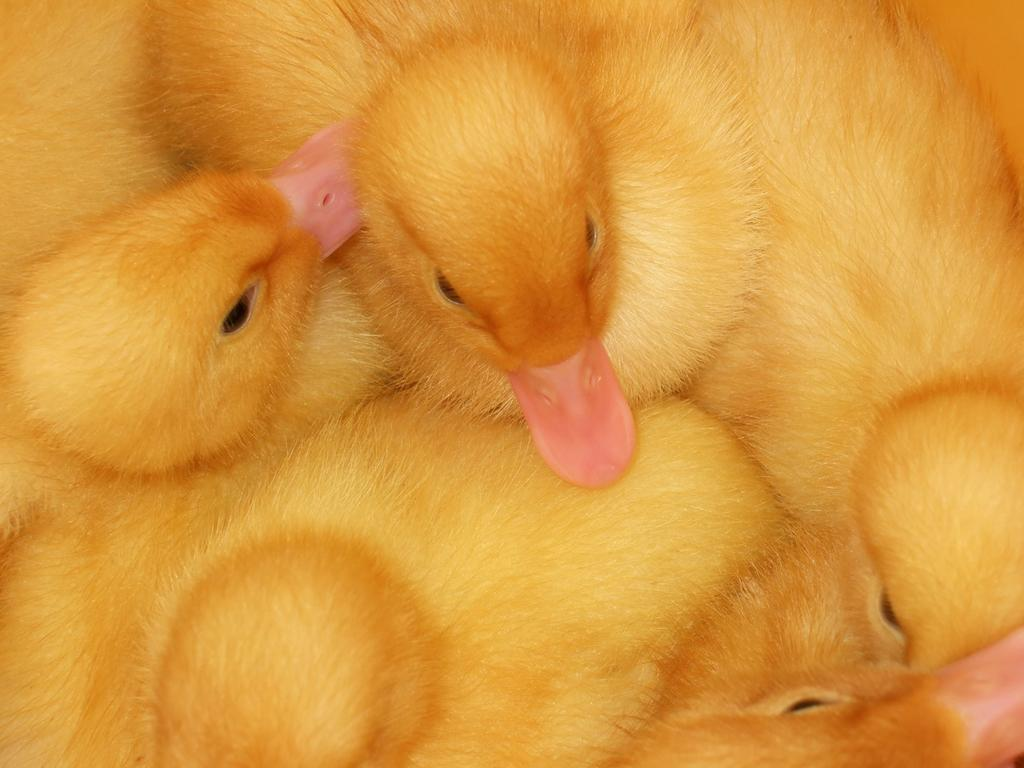What type of animals are present in the image? There is a group of ducklings in the image. What type of toothbrush is being used by the ducklings in the image? There is no toothbrush present in the image; it features a group of ducklings. What message of peace can be seen in the image? There is no message of peace depicted in the image; it features a group of ducklings. 